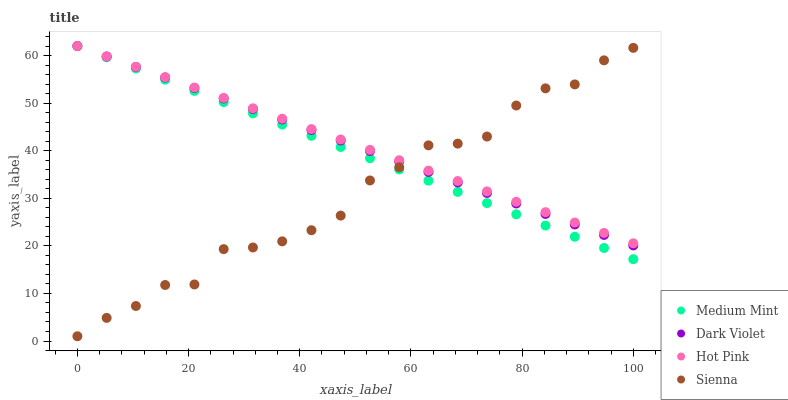Does Sienna have the minimum area under the curve?
Answer yes or no. Yes. Does Hot Pink have the maximum area under the curve?
Answer yes or no. Yes. Does Hot Pink have the minimum area under the curve?
Answer yes or no. No. Does Sienna have the maximum area under the curve?
Answer yes or no. No. Is Dark Violet the smoothest?
Answer yes or no. Yes. Is Sienna the roughest?
Answer yes or no. Yes. Is Hot Pink the smoothest?
Answer yes or no. No. Is Hot Pink the roughest?
Answer yes or no. No. Does Sienna have the lowest value?
Answer yes or no. Yes. Does Hot Pink have the lowest value?
Answer yes or no. No. Does Dark Violet have the highest value?
Answer yes or no. Yes. Does Sienna have the highest value?
Answer yes or no. No. Does Dark Violet intersect Medium Mint?
Answer yes or no. Yes. Is Dark Violet less than Medium Mint?
Answer yes or no. No. Is Dark Violet greater than Medium Mint?
Answer yes or no. No. 